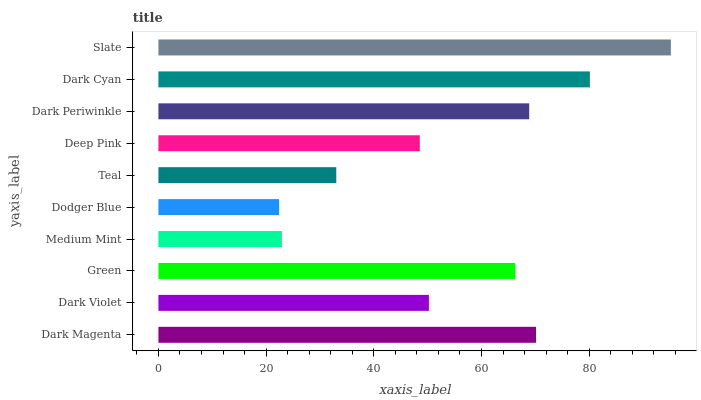Is Dodger Blue the minimum?
Answer yes or no. Yes. Is Slate the maximum?
Answer yes or no. Yes. Is Dark Violet the minimum?
Answer yes or no. No. Is Dark Violet the maximum?
Answer yes or no. No. Is Dark Magenta greater than Dark Violet?
Answer yes or no. Yes. Is Dark Violet less than Dark Magenta?
Answer yes or no. Yes. Is Dark Violet greater than Dark Magenta?
Answer yes or no. No. Is Dark Magenta less than Dark Violet?
Answer yes or no. No. Is Green the high median?
Answer yes or no. Yes. Is Dark Violet the low median?
Answer yes or no. Yes. Is Deep Pink the high median?
Answer yes or no. No. Is Dark Periwinkle the low median?
Answer yes or no. No. 